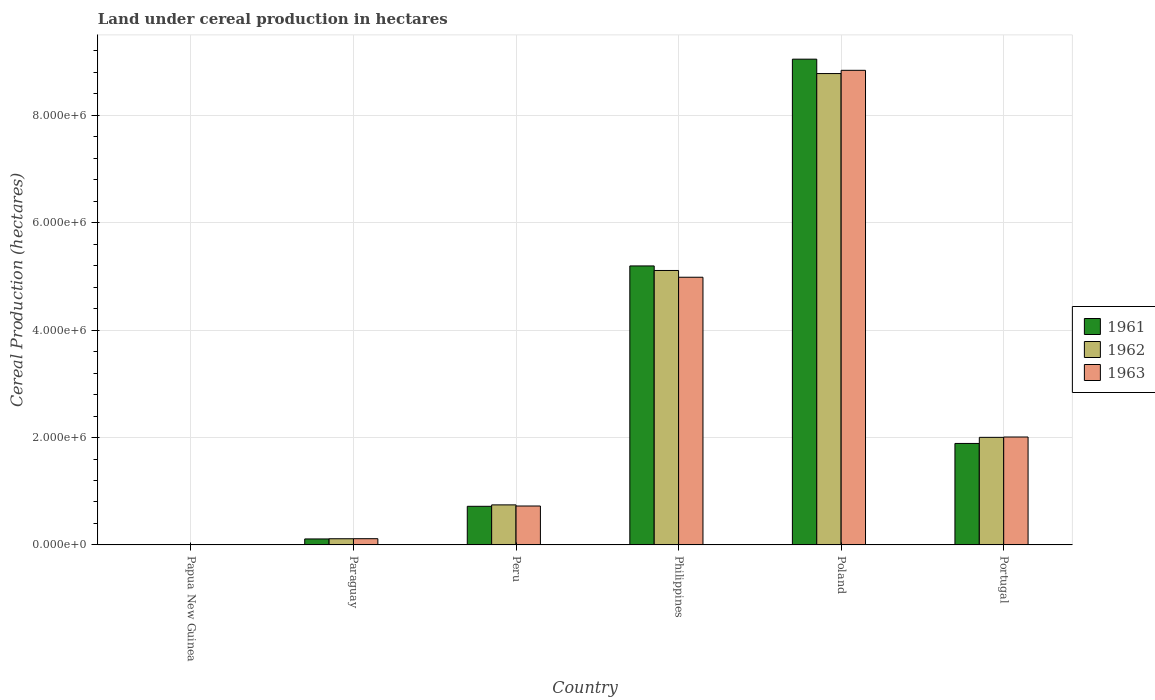Are the number of bars on each tick of the X-axis equal?
Ensure brevity in your answer.  Yes. What is the label of the 1st group of bars from the left?
Your answer should be compact. Papua New Guinea. In how many cases, is the number of bars for a given country not equal to the number of legend labels?
Offer a very short reply. 0. What is the land under cereal production in 1962 in Peru?
Provide a short and direct response. 7.46e+05. Across all countries, what is the maximum land under cereal production in 1962?
Offer a very short reply. 8.78e+06. Across all countries, what is the minimum land under cereal production in 1961?
Give a very brief answer. 659. In which country was the land under cereal production in 1962 maximum?
Your answer should be compact. Poland. In which country was the land under cereal production in 1962 minimum?
Ensure brevity in your answer.  Papua New Guinea. What is the total land under cereal production in 1962 in the graph?
Your response must be concise. 1.68e+07. What is the difference between the land under cereal production in 1963 in Poland and that in Portugal?
Your answer should be very brief. 6.83e+06. What is the difference between the land under cereal production in 1962 in Paraguay and the land under cereal production in 1961 in Papua New Guinea?
Your response must be concise. 1.15e+05. What is the average land under cereal production in 1961 per country?
Your answer should be very brief. 2.83e+06. What is the difference between the land under cereal production of/in 1963 and land under cereal production of/in 1961 in Portugal?
Provide a succinct answer. 1.20e+05. What is the ratio of the land under cereal production in 1963 in Papua New Guinea to that in Peru?
Make the answer very short. 0. What is the difference between the highest and the second highest land under cereal production in 1963?
Your response must be concise. 2.98e+06. What is the difference between the highest and the lowest land under cereal production in 1963?
Keep it short and to the point. 8.84e+06. Is the sum of the land under cereal production in 1963 in Papua New Guinea and Poland greater than the maximum land under cereal production in 1961 across all countries?
Keep it short and to the point. No. What does the 1st bar from the right in Peru represents?
Make the answer very short. 1963. Is it the case that in every country, the sum of the land under cereal production in 1962 and land under cereal production in 1963 is greater than the land under cereal production in 1961?
Give a very brief answer. Yes. Are all the bars in the graph horizontal?
Your response must be concise. No. What is the difference between two consecutive major ticks on the Y-axis?
Offer a terse response. 2.00e+06. Are the values on the major ticks of Y-axis written in scientific E-notation?
Make the answer very short. Yes. Does the graph contain any zero values?
Provide a succinct answer. No. Does the graph contain grids?
Provide a short and direct response. Yes. Where does the legend appear in the graph?
Provide a succinct answer. Center right. What is the title of the graph?
Provide a short and direct response. Land under cereal production in hectares. What is the label or title of the Y-axis?
Keep it short and to the point. Cereal Production (hectares). What is the Cereal Production (hectares) in 1961 in Papua New Guinea?
Your answer should be compact. 659. What is the Cereal Production (hectares) in 1962 in Papua New Guinea?
Offer a terse response. 728. What is the Cereal Production (hectares) of 1963 in Papua New Guinea?
Your response must be concise. 737. What is the Cereal Production (hectares) in 1961 in Paraguay?
Your response must be concise. 1.12e+05. What is the Cereal Production (hectares) in 1962 in Paraguay?
Make the answer very short. 1.15e+05. What is the Cereal Production (hectares) in 1963 in Paraguay?
Offer a very short reply. 1.16e+05. What is the Cereal Production (hectares) of 1961 in Peru?
Give a very brief answer. 7.19e+05. What is the Cereal Production (hectares) of 1962 in Peru?
Your response must be concise. 7.46e+05. What is the Cereal Production (hectares) in 1963 in Peru?
Keep it short and to the point. 7.25e+05. What is the Cereal Production (hectares) in 1961 in Philippines?
Keep it short and to the point. 5.20e+06. What is the Cereal Production (hectares) of 1962 in Philippines?
Give a very brief answer. 5.11e+06. What is the Cereal Production (hectares) in 1963 in Philippines?
Give a very brief answer. 4.99e+06. What is the Cereal Production (hectares) in 1961 in Poland?
Make the answer very short. 9.05e+06. What is the Cereal Production (hectares) in 1962 in Poland?
Your response must be concise. 8.78e+06. What is the Cereal Production (hectares) of 1963 in Poland?
Provide a short and direct response. 8.84e+06. What is the Cereal Production (hectares) of 1961 in Portugal?
Your answer should be very brief. 1.89e+06. What is the Cereal Production (hectares) of 1962 in Portugal?
Make the answer very short. 2.00e+06. What is the Cereal Production (hectares) of 1963 in Portugal?
Your response must be concise. 2.01e+06. Across all countries, what is the maximum Cereal Production (hectares) in 1961?
Give a very brief answer. 9.05e+06. Across all countries, what is the maximum Cereal Production (hectares) of 1962?
Your response must be concise. 8.78e+06. Across all countries, what is the maximum Cereal Production (hectares) in 1963?
Ensure brevity in your answer.  8.84e+06. Across all countries, what is the minimum Cereal Production (hectares) in 1961?
Your response must be concise. 659. Across all countries, what is the minimum Cereal Production (hectares) of 1962?
Offer a very short reply. 728. Across all countries, what is the minimum Cereal Production (hectares) in 1963?
Your response must be concise. 737. What is the total Cereal Production (hectares) of 1961 in the graph?
Offer a very short reply. 1.70e+07. What is the total Cereal Production (hectares) of 1962 in the graph?
Provide a short and direct response. 1.68e+07. What is the total Cereal Production (hectares) in 1963 in the graph?
Your answer should be very brief. 1.67e+07. What is the difference between the Cereal Production (hectares) of 1961 in Papua New Guinea and that in Paraguay?
Make the answer very short. -1.11e+05. What is the difference between the Cereal Production (hectares) of 1962 in Papua New Guinea and that in Paraguay?
Your answer should be compact. -1.14e+05. What is the difference between the Cereal Production (hectares) in 1963 in Papua New Guinea and that in Paraguay?
Keep it short and to the point. -1.15e+05. What is the difference between the Cereal Production (hectares) in 1961 in Papua New Guinea and that in Peru?
Offer a very short reply. -7.19e+05. What is the difference between the Cereal Production (hectares) in 1962 in Papua New Guinea and that in Peru?
Offer a terse response. -7.45e+05. What is the difference between the Cereal Production (hectares) of 1963 in Papua New Guinea and that in Peru?
Your answer should be compact. -7.24e+05. What is the difference between the Cereal Production (hectares) of 1961 in Papua New Guinea and that in Philippines?
Offer a terse response. -5.19e+06. What is the difference between the Cereal Production (hectares) in 1962 in Papua New Guinea and that in Philippines?
Give a very brief answer. -5.11e+06. What is the difference between the Cereal Production (hectares) in 1963 in Papua New Guinea and that in Philippines?
Provide a short and direct response. -4.98e+06. What is the difference between the Cereal Production (hectares) in 1961 in Papua New Guinea and that in Poland?
Your answer should be very brief. -9.05e+06. What is the difference between the Cereal Production (hectares) of 1962 in Papua New Guinea and that in Poland?
Give a very brief answer. -8.78e+06. What is the difference between the Cereal Production (hectares) of 1963 in Papua New Guinea and that in Poland?
Keep it short and to the point. -8.84e+06. What is the difference between the Cereal Production (hectares) in 1961 in Papua New Guinea and that in Portugal?
Make the answer very short. -1.89e+06. What is the difference between the Cereal Production (hectares) of 1962 in Papua New Guinea and that in Portugal?
Your response must be concise. -2.00e+06. What is the difference between the Cereal Production (hectares) in 1963 in Papua New Guinea and that in Portugal?
Ensure brevity in your answer.  -2.01e+06. What is the difference between the Cereal Production (hectares) in 1961 in Paraguay and that in Peru?
Make the answer very short. -6.08e+05. What is the difference between the Cereal Production (hectares) of 1962 in Paraguay and that in Peru?
Ensure brevity in your answer.  -6.31e+05. What is the difference between the Cereal Production (hectares) of 1963 in Paraguay and that in Peru?
Provide a succinct answer. -6.09e+05. What is the difference between the Cereal Production (hectares) of 1961 in Paraguay and that in Philippines?
Offer a very short reply. -5.08e+06. What is the difference between the Cereal Production (hectares) in 1962 in Paraguay and that in Philippines?
Make the answer very short. -5.00e+06. What is the difference between the Cereal Production (hectares) in 1963 in Paraguay and that in Philippines?
Offer a very short reply. -4.87e+06. What is the difference between the Cereal Production (hectares) in 1961 in Paraguay and that in Poland?
Ensure brevity in your answer.  -8.93e+06. What is the difference between the Cereal Production (hectares) in 1962 in Paraguay and that in Poland?
Offer a very short reply. -8.66e+06. What is the difference between the Cereal Production (hectares) in 1963 in Paraguay and that in Poland?
Provide a short and direct response. -8.72e+06. What is the difference between the Cereal Production (hectares) in 1961 in Paraguay and that in Portugal?
Offer a terse response. -1.78e+06. What is the difference between the Cereal Production (hectares) in 1962 in Paraguay and that in Portugal?
Offer a terse response. -1.89e+06. What is the difference between the Cereal Production (hectares) in 1963 in Paraguay and that in Portugal?
Offer a terse response. -1.89e+06. What is the difference between the Cereal Production (hectares) of 1961 in Peru and that in Philippines?
Offer a terse response. -4.48e+06. What is the difference between the Cereal Production (hectares) of 1962 in Peru and that in Philippines?
Make the answer very short. -4.37e+06. What is the difference between the Cereal Production (hectares) in 1963 in Peru and that in Philippines?
Offer a terse response. -4.26e+06. What is the difference between the Cereal Production (hectares) of 1961 in Peru and that in Poland?
Your answer should be very brief. -8.33e+06. What is the difference between the Cereal Production (hectares) in 1962 in Peru and that in Poland?
Keep it short and to the point. -8.03e+06. What is the difference between the Cereal Production (hectares) in 1963 in Peru and that in Poland?
Your answer should be compact. -8.11e+06. What is the difference between the Cereal Production (hectares) in 1961 in Peru and that in Portugal?
Ensure brevity in your answer.  -1.17e+06. What is the difference between the Cereal Production (hectares) in 1962 in Peru and that in Portugal?
Keep it short and to the point. -1.26e+06. What is the difference between the Cereal Production (hectares) in 1963 in Peru and that in Portugal?
Give a very brief answer. -1.28e+06. What is the difference between the Cereal Production (hectares) of 1961 in Philippines and that in Poland?
Offer a terse response. -3.85e+06. What is the difference between the Cereal Production (hectares) of 1962 in Philippines and that in Poland?
Provide a short and direct response. -3.67e+06. What is the difference between the Cereal Production (hectares) in 1963 in Philippines and that in Poland?
Offer a very short reply. -3.85e+06. What is the difference between the Cereal Production (hectares) in 1961 in Philippines and that in Portugal?
Your answer should be compact. 3.31e+06. What is the difference between the Cereal Production (hectares) of 1962 in Philippines and that in Portugal?
Your answer should be compact. 3.11e+06. What is the difference between the Cereal Production (hectares) in 1963 in Philippines and that in Portugal?
Give a very brief answer. 2.98e+06. What is the difference between the Cereal Production (hectares) of 1961 in Poland and that in Portugal?
Ensure brevity in your answer.  7.16e+06. What is the difference between the Cereal Production (hectares) of 1962 in Poland and that in Portugal?
Make the answer very short. 6.77e+06. What is the difference between the Cereal Production (hectares) of 1963 in Poland and that in Portugal?
Make the answer very short. 6.83e+06. What is the difference between the Cereal Production (hectares) of 1961 in Papua New Guinea and the Cereal Production (hectares) of 1962 in Paraguay?
Give a very brief answer. -1.15e+05. What is the difference between the Cereal Production (hectares) of 1961 in Papua New Guinea and the Cereal Production (hectares) of 1963 in Paraguay?
Offer a very short reply. -1.15e+05. What is the difference between the Cereal Production (hectares) in 1962 in Papua New Guinea and the Cereal Production (hectares) in 1963 in Paraguay?
Your answer should be compact. -1.15e+05. What is the difference between the Cereal Production (hectares) of 1961 in Papua New Guinea and the Cereal Production (hectares) of 1962 in Peru?
Give a very brief answer. -7.45e+05. What is the difference between the Cereal Production (hectares) in 1961 in Papua New Guinea and the Cereal Production (hectares) in 1963 in Peru?
Offer a very short reply. -7.24e+05. What is the difference between the Cereal Production (hectares) of 1962 in Papua New Guinea and the Cereal Production (hectares) of 1963 in Peru?
Your response must be concise. -7.24e+05. What is the difference between the Cereal Production (hectares) of 1961 in Papua New Guinea and the Cereal Production (hectares) of 1962 in Philippines?
Offer a very short reply. -5.11e+06. What is the difference between the Cereal Production (hectares) in 1961 in Papua New Guinea and the Cereal Production (hectares) in 1963 in Philippines?
Ensure brevity in your answer.  -4.98e+06. What is the difference between the Cereal Production (hectares) in 1962 in Papua New Guinea and the Cereal Production (hectares) in 1963 in Philippines?
Ensure brevity in your answer.  -4.98e+06. What is the difference between the Cereal Production (hectares) of 1961 in Papua New Guinea and the Cereal Production (hectares) of 1962 in Poland?
Keep it short and to the point. -8.78e+06. What is the difference between the Cereal Production (hectares) in 1961 in Papua New Guinea and the Cereal Production (hectares) in 1963 in Poland?
Provide a succinct answer. -8.84e+06. What is the difference between the Cereal Production (hectares) in 1962 in Papua New Guinea and the Cereal Production (hectares) in 1963 in Poland?
Provide a succinct answer. -8.84e+06. What is the difference between the Cereal Production (hectares) of 1961 in Papua New Guinea and the Cereal Production (hectares) of 1962 in Portugal?
Offer a very short reply. -2.00e+06. What is the difference between the Cereal Production (hectares) in 1961 in Papua New Guinea and the Cereal Production (hectares) in 1963 in Portugal?
Your answer should be compact. -2.01e+06. What is the difference between the Cereal Production (hectares) of 1962 in Papua New Guinea and the Cereal Production (hectares) of 1963 in Portugal?
Provide a short and direct response. -2.01e+06. What is the difference between the Cereal Production (hectares) in 1961 in Paraguay and the Cereal Production (hectares) in 1962 in Peru?
Make the answer very short. -6.34e+05. What is the difference between the Cereal Production (hectares) of 1961 in Paraguay and the Cereal Production (hectares) of 1963 in Peru?
Your answer should be very brief. -6.13e+05. What is the difference between the Cereal Production (hectares) of 1962 in Paraguay and the Cereal Production (hectares) of 1963 in Peru?
Keep it short and to the point. -6.10e+05. What is the difference between the Cereal Production (hectares) in 1961 in Paraguay and the Cereal Production (hectares) in 1962 in Philippines?
Keep it short and to the point. -5.00e+06. What is the difference between the Cereal Production (hectares) in 1961 in Paraguay and the Cereal Production (hectares) in 1963 in Philippines?
Provide a succinct answer. -4.87e+06. What is the difference between the Cereal Production (hectares) of 1962 in Paraguay and the Cereal Production (hectares) of 1963 in Philippines?
Ensure brevity in your answer.  -4.87e+06. What is the difference between the Cereal Production (hectares) of 1961 in Paraguay and the Cereal Production (hectares) of 1962 in Poland?
Your answer should be compact. -8.67e+06. What is the difference between the Cereal Production (hectares) of 1961 in Paraguay and the Cereal Production (hectares) of 1963 in Poland?
Give a very brief answer. -8.73e+06. What is the difference between the Cereal Production (hectares) of 1962 in Paraguay and the Cereal Production (hectares) of 1963 in Poland?
Make the answer very short. -8.72e+06. What is the difference between the Cereal Production (hectares) of 1961 in Paraguay and the Cereal Production (hectares) of 1962 in Portugal?
Provide a succinct answer. -1.89e+06. What is the difference between the Cereal Production (hectares) of 1961 in Paraguay and the Cereal Production (hectares) of 1963 in Portugal?
Ensure brevity in your answer.  -1.90e+06. What is the difference between the Cereal Production (hectares) in 1962 in Paraguay and the Cereal Production (hectares) in 1963 in Portugal?
Provide a short and direct response. -1.89e+06. What is the difference between the Cereal Production (hectares) of 1961 in Peru and the Cereal Production (hectares) of 1962 in Philippines?
Provide a short and direct response. -4.39e+06. What is the difference between the Cereal Production (hectares) of 1961 in Peru and the Cereal Production (hectares) of 1963 in Philippines?
Your response must be concise. -4.27e+06. What is the difference between the Cereal Production (hectares) in 1962 in Peru and the Cereal Production (hectares) in 1963 in Philippines?
Keep it short and to the point. -4.24e+06. What is the difference between the Cereal Production (hectares) of 1961 in Peru and the Cereal Production (hectares) of 1962 in Poland?
Keep it short and to the point. -8.06e+06. What is the difference between the Cereal Production (hectares) of 1961 in Peru and the Cereal Production (hectares) of 1963 in Poland?
Your answer should be compact. -8.12e+06. What is the difference between the Cereal Production (hectares) in 1962 in Peru and the Cereal Production (hectares) in 1963 in Poland?
Ensure brevity in your answer.  -8.09e+06. What is the difference between the Cereal Production (hectares) in 1961 in Peru and the Cereal Production (hectares) in 1962 in Portugal?
Offer a terse response. -1.28e+06. What is the difference between the Cereal Production (hectares) in 1961 in Peru and the Cereal Production (hectares) in 1963 in Portugal?
Your answer should be very brief. -1.29e+06. What is the difference between the Cereal Production (hectares) of 1962 in Peru and the Cereal Production (hectares) of 1963 in Portugal?
Provide a short and direct response. -1.26e+06. What is the difference between the Cereal Production (hectares) in 1961 in Philippines and the Cereal Production (hectares) in 1962 in Poland?
Give a very brief answer. -3.58e+06. What is the difference between the Cereal Production (hectares) in 1961 in Philippines and the Cereal Production (hectares) in 1963 in Poland?
Keep it short and to the point. -3.64e+06. What is the difference between the Cereal Production (hectares) in 1962 in Philippines and the Cereal Production (hectares) in 1963 in Poland?
Your response must be concise. -3.73e+06. What is the difference between the Cereal Production (hectares) of 1961 in Philippines and the Cereal Production (hectares) of 1962 in Portugal?
Provide a succinct answer. 3.19e+06. What is the difference between the Cereal Production (hectares) in 1961 in Philippines and the Cereal Production (hectares) in 1963 in Portugal?
Provide a succinct answer. 3.19e+06. What is the difference between the Cereal Production (hectares) in 1962 in Philippines and the Cereal Production (hectares) in 1963 in Portugal?
Your answer should be compact. 3.10e+06. What is the difference between the Cereal Production (hectares) of 1961 in Poland and the Cereal Production (hectares) of 1962 in Portugal?
Provide a short and direct response. 7.04e+06. What is the difference between the Cereal Production (hectares) in 1961 in Poland and the Cereal Production (hectares) in 1963 in Portugal?
Provide a succinct answer. 7.04e+06. What is the difference between the Cereal Production (hectares) of 1962 in Poland and the Cereal Production (hectares) of 1963 in Portugal?
Offer a terse response. 6.77e+06. What is the average Cereal Production (hectares) of 1961 per country?
Your answer should be compact. 2.83e+06. What is the average Cereal Production (hectares) in 1962 per country?
Your answer should be compact. 2.79e+06. What is the average Cereal Production (hectares) of 1963 per country?
Offer a very short reply. 2.78e+06. What is the difference between the Cereal Production (hectares) in 1961 and Cereal Production (hectares) in 1962 in Papua New Guinea?
Your answer should be compact. -69. What is the difference between the Cereal Production (hectares) of 1961 and Cereal Production (hectares) of 1963 in Papua New Guinea?
Your answer should be very brief. -78. What is the difference between the Cereal Production (hectares) of 1961 and Cereal Production (hectares) of 1962 in Paraguay?
Make the answer very short. -3600. What is the difference between the Cereal Production (hectares) of 1961 and Cereal Production (hectares) of 1963 in Paraguay?
Ensure brevity in your answer.  -4500. What is the difference between the Cereal Production (hectares) in 1962 and Cereal Production (hectares) in 1963 in Paraguay?
Keep it short and to the point. -900. What is the difference between the Cereal Production (hectares) of 1961 and Cereal Production (hectares) of 1962 in Peru?
Provide a short and direct response. -2.65e+04. What is the difference between the Cereal Production (hectares) in 1961 and Cereal Production (hectares) in 1963 in Peru?
Your response must be concise. -5665. What is the difference between the Cereal Production (hectares) of 1962 and Cereal Production (hectares) of 1963 in Peru?
Give a very brief answer. 2.09e+04. What is the difference between the Cereal Production (hectares) of 1961 and Cereal Production (hectares) of 1962 in Philippines?
Offer a very short reply. 8.46e+04. What is the difference between the Cereal Production (hectares) of 1961 and Cereal Production (hectares) of 1963 in Philippines?
Offer a very short reply. 2.10e+05. What is the difference between the Cereal Production (hectares) in 1962 and Cereal Production (hectares) in 1963 in Philippines?
Offer a terse response. 1.26e+05. What is the difference between the Cereal Production (hectares) of 1961 and Cereal Production (hectares) of 1962 in Poland?
Ensure brevity in your answer.  2.68e+05. What is the difference between the Cereal Production (hectares) in 1961 and Cereal Production (hectares) in 1963 in Poland?
Provide a short and direct response. 2.08e+05. What is the difference between the Cereal Production (hectares) of 1962 and Cereal Production (hectares) of 1963 in Poland?
Provide a short and direct response. -6.03e+04. What is the difference between the Cereal Production (hectares) in 1961 and Cereal Production (hectares) in 1962 in Portugal?
Provide a short and direct response. -1.13e+05. What is the difference between the Cereal Production (hectares) of 1961 and Cereal Production (hectares) of 1963 in Portugal?
Make the answer very short. -1.20e+05. What is the difference between the Cereal Production (hectares) in 1962 and Cereal Production (hectares) in 1963 in Portugal?
Ensure brevity in your answer.  -6451. What is the ratio of the Cereal Production (hectares) in 1961 in Papua New Guinea to that in Paraguay?
Ensure brevity in your answer.  0.01. What is the ratio of the Cereal Production (hectares) in 1962 in Papua New Guinea to that in Paraguay?
Provide a succinct answer. 0.01. What is the ratio of the Cereal Production (hectares) of 1963 in Papua New Guinea to that in Paraguay?
Ensure brevity in your answer.  0.01. What is the ratio of the Cereal Production (hectares) of 1961 in Papua New Guinea to that in Peru?
Provide a succinct answer. 0. What is the ratio of the Cereal Production (hectares) of 1962 in Papua New Guinea to that in Peru?
Your answer should be very brief. 0. What is the ratio of the Cereal Production (hectares) of 1962 in Papua New Guinea to that in Philippines?
Offer a very short reply. 0. What is the ratio of the Cereal Production (hectares) of 1961 in Papua New Guinea to that in Poland?
Your answer should be compact. 0. What is the ratio of the Cereal Production (hectares) in 1963 in Papua New Guinea to that in Portugal?
Provide a short and direct response. 0. What is the ratio of the Cereal Production (hectares) in 1961 in Paraguay to that in Peru?
Your answer should be very brief. 0.16. What is the ratio of the Cereal Production (hectares) of 1962 in Paraguay to that in Peru?
Offer a terse response. 0.15. What is the ratio of the Cereal Production (hectares) in 1963 in Paraguay to that in Peru?
Make the answer very short. 0.16. What is the ratio of the Cereal Production (hectares) of 1961 in Paraguay to that in Philippines?
Offer a very short reply. 0.02. What is the ratio of the Cereal Production (hectares) of 1962 in Paraguay to that in Philippines?
Provide a short and direct response. 0.02. What is the ratio of the Cereal Production (hectares) in 1963 in Paraguay to that in Philippines?
Make the answer very short. 0.02. What is the ratio of the Cereal Production (hectares) in 1961 in Paraguay to that in Poland?
Make the answer very short. 0.01. What is the ratio of the Cereal Production (hectares) of 1962 in Paraguay to that in Poland?
Give a very brief answer. 0.01. What is the ratio of the Cereal Production (hectares) in 1963 in Paraguay to that in Poland?
Offer a very short reply. 0.01. What is the ratio of the Cereal Production (hectares) of 1961 in Paraguay to that in Portugal?
Make the answer very short. 0.06. What is the ratio of the Cereal Production (hectares) in 1962 in Paraguay to that in Portugal?
Provide a short and direct response. 0.06. What is the ratio of the Cereal Production (hectares) of 1963 in Paraguay to that in Portugal?
Keep it short and to the point. 0.06. What is the ratio of the Cereal Production (hectares) of 1961 in Peru to that in Philippines?
Provide a short and direct response. 0.14. What is the ratio of the Cereal Production (hectares) in 1962 in Peru to that in Philippines?
Your response must be concise. 0.15. What is the ratio of the Cereal Production (hectares) of 1963 in Peru to that in Philippines?
Provide a short and direct response. 0.15. What is the ratio of the Cereal Production (hectares) of 1961 in Peru to that in Poland?
Keep it short and to the point. 0.08. What is the ratio of the Cereal Production (hectares) in 1962 in Peru to that in Poland?
Ensure brevity in your answer.  0.09. What is the ratio of the Cereal Production (hectares) of 1963 in Peru to that in Poland?
Offer a very short reply. 0.08. What is the ratio of the Cereal Production (hectares) of 1961 in Peru to that in Portugal?
Ensure brevity in your answer.  0.38. What is the ratio of the Cereal Production (hectares) of 1962 in Peru to that in Portugal?
Keep it short and to the point. 0.37. What is the ratio of the Cereal Production (hectares) of 1963 in Peru to that in Portugal?
Provide a succinct answer. 0.36. What is the ratio of the Cereal Production (hectares) in 1961 in Philippines to that in Poland?
Offer a terse response. 0.57. What is the ratio of the Cereal Production (hectares) in 1962 in Philippines to that in Poland?
Provide a succinct answer. 0.58. What is the ratio of the Cereal Production (hectares) of 1963 in Philippines to that in Poland?
Provide a succinct answer. 0.56. What is the ratio of the Cereal Production (hectares) in 1961 in Philippines to that in Portugal?
Offer a terse response. 2.75. What is the ratio of the Cereal Production (hectares) of 1962 in Philippines to that in Portugal?
Offer a terse response. 2.55. What is the ratio of the Cereal Production (hectares) of 1963 in Philippines to that in Portugal?
Offer a terse response. 2.48. What is the ratio of the Cereal Production (hectares) in 1961 in Poland to that in Portugal?
Offer a terse response. 4.79. What is the ratio of the Cereal Production (hectares) of 1962 in Poland to that in Portugal?
Make the answer very short. 4.38. What is the ratio of the Cereal Production (hectares) in 1963 in Poland to that in Portugal?
Ensure brevity in your answer.  4.4. What is the difference between the highest and the second highest Cereal Production (hectares) of 1961?
Offer a terse response. 3.85e+06. What is the difference between the highest and the second highest Cereal Production (hectares) in 1962?
Your response must be concise. 3.67e+06. What is the difference between the highest and the second highest Cereal Production (hectares) in 1963?
Give a very brief answer. 3.85e+06. What is the difference between the highest and the lowest Cereal Production (hectares) of 1961?
Give a very brief answer. 9.05e+06. What is the difference between the highest and the lowest Cereal Production (hectares) of 1962?
Keep it short and to the point. 8.78e+06. What is the difference between the highest and the lowest Cereal Production (hectares) of 1963?
Make the answer very short. 8.84e+06. 